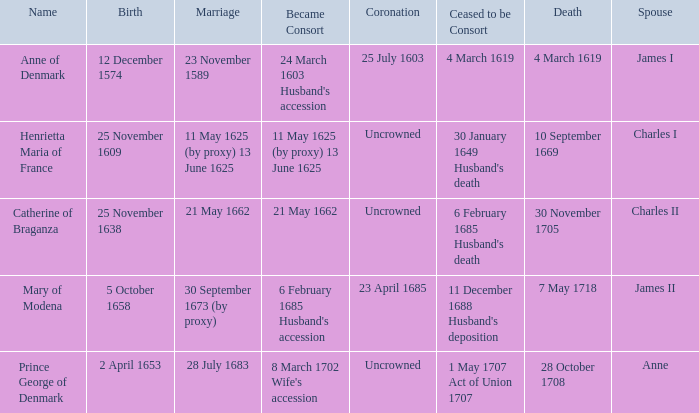When did the spouse of charles ii pass away? 30 November 1705. 